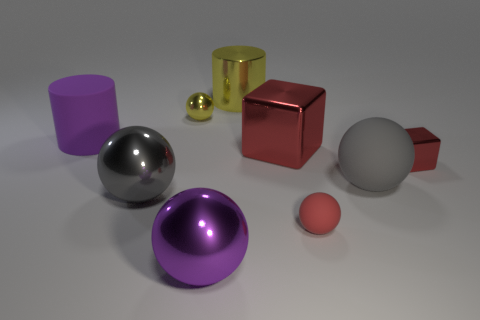Subtract all red matte spheres. How many spheres are left? 4 Subtract all gray balls. How many balls are left? 3 Subtract 1 cubes. How many cubes are left? 1 Subtract all cubes. How many objects are left? 7 Add 8 large purple cylinders. How many large purple cylinders are left? 9 Add 1 small yellow matte balls. How many small yellow matte balls exist? 1 Subtract 0 brown balls. How many objects are left? 9 Subtract all blue cylinders. Subtract all brown cubes. How many cylinders are left? 2 Subtract all brown balls. How many gray cylinders are left? 0 Subtract all cyan matte balls. Subtract all red objects. How many objects are left? 6 